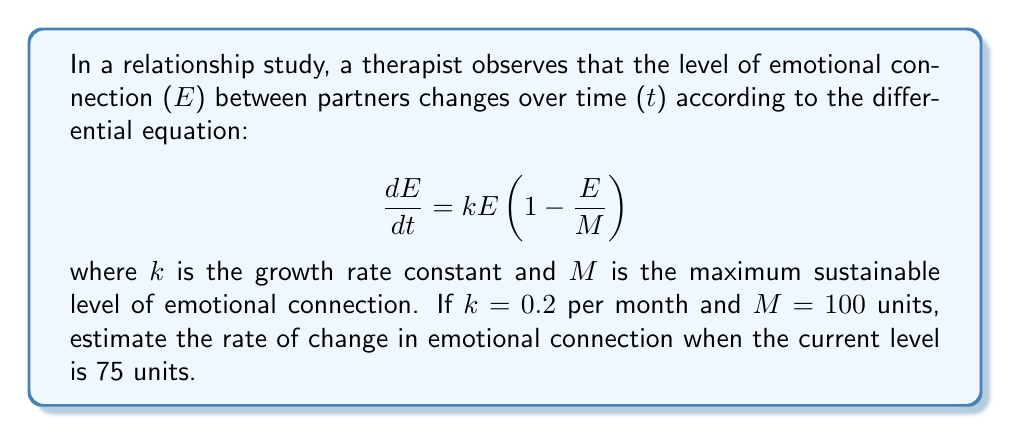Give your solution to this math problem. To solve this problem, we'll follow these steps:

1) We're given the differential equation:
   $$\frac{dE}{dt} = kE(1 - \frac{E}{M})$$

2) We know the following values:
   $k = 0.2$ per month
   $M = 100$ units
   $E = 75$ units (current level)

3) Let's substitute these values into the equation:
   $$\frac{dE}{dt} = 0.2 \cdot 75 \cdot (1 - \frac{75}{100})$$

4) First, let's calculate the term inside the parentheses:
   $$1 - \frac{75}{100} = 1 - 0.75 = 0.25$$

5) Now, we can multiply:
   $$\frac{dE}{dt} = 0.2 \cdot 75 \cdot 0.25 = 15 \cdot 0.25 = 3.75$$

6) Therefore, the rate of change in emotional connection at this point is 3.75 units per month.

This positive rate indicates that the emotional connection is still growing, but at a slower rate than it would at lower levels of connection. As the connection level approaches the maximum (100 units), the growth rate will slow down even further.
Answer: 3.75 units per month 